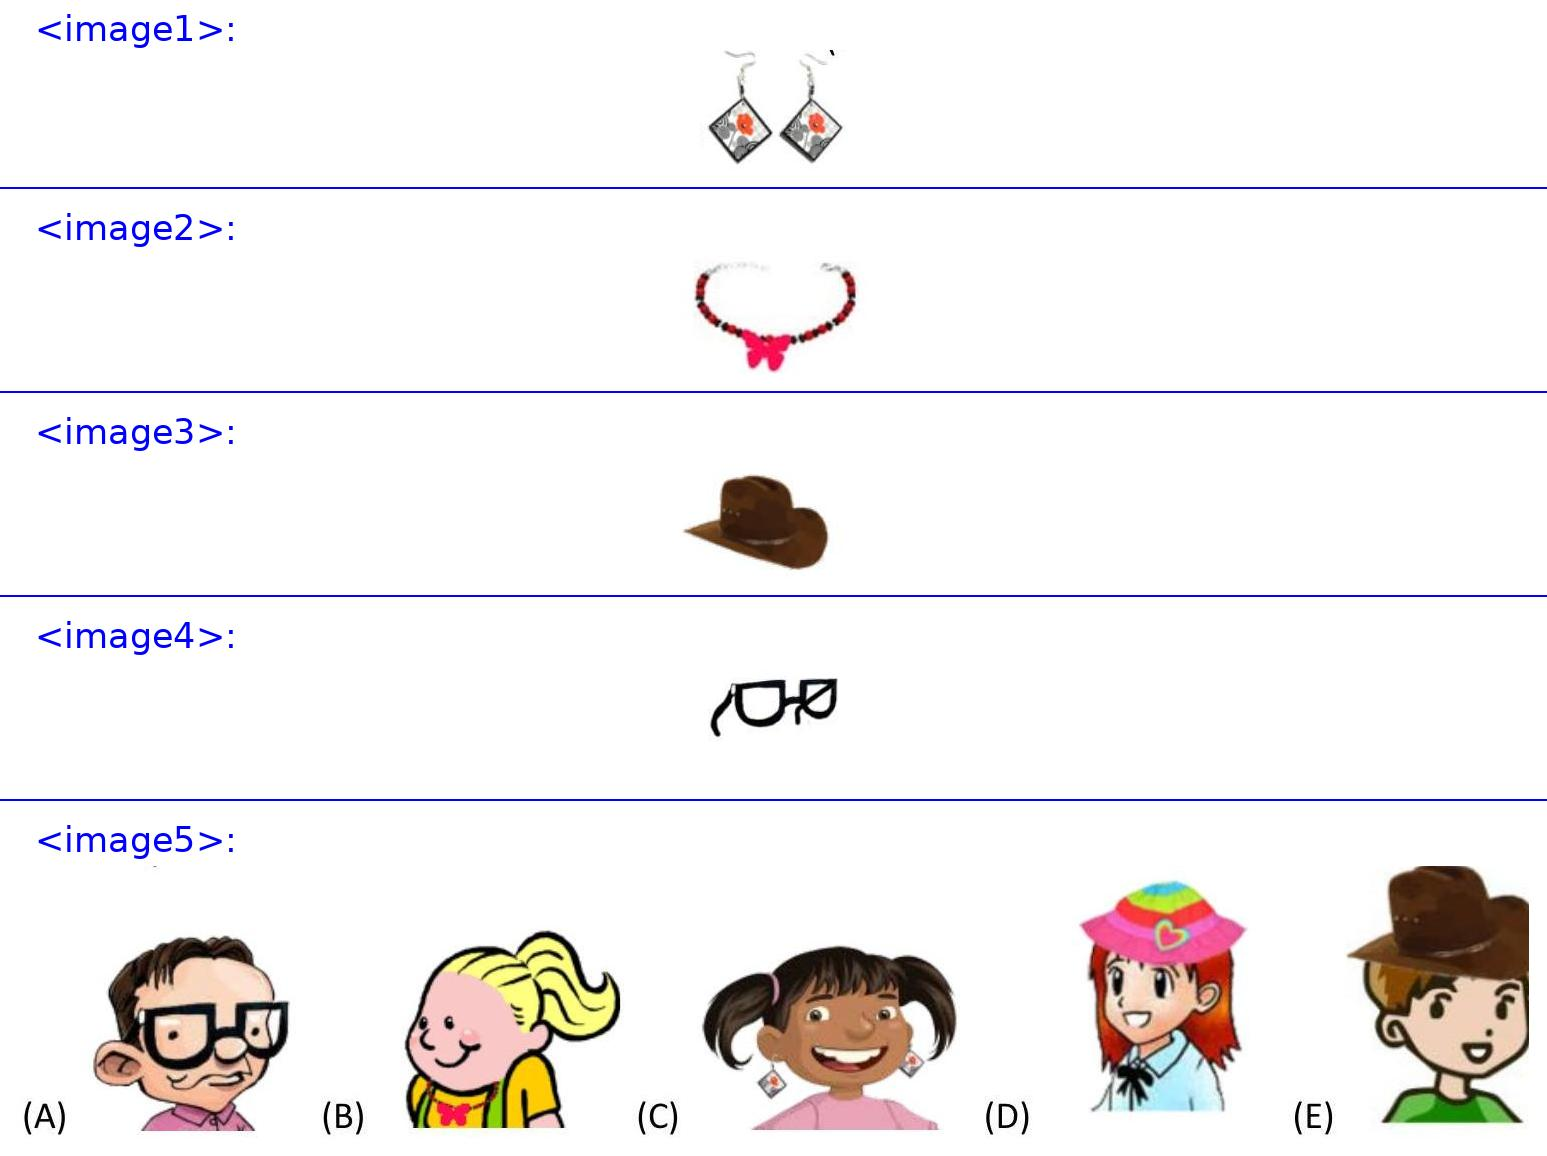Anna has <image1>.
Barbara gave Eva <image2>.
Josef has a <image3>.
Bob has <image4>.
Who is Barbara?
<image5> Choices: ['A', 'B', 'C', 'D', 'E'] Barbara is the girl shown in choice (D) as she is wearing the item depicted in <image2>, which is a red necklace with a bow in the center. It matches the description given for Eva, whom Barbara gifted this necklace to. This detail helps in identifying Barbara correctly among the choices. 